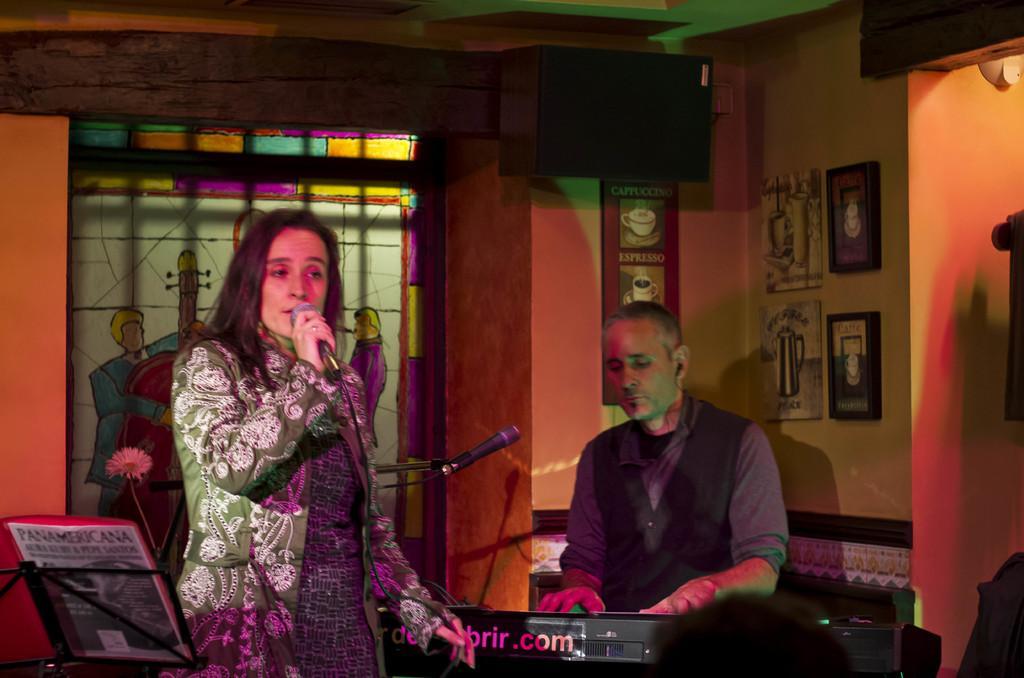In one or two sentences, can you explain what this image depicts? This picture is clicked inside a room. The woman to the left corner is holding a microphone in a hand and singing. The man to the right corner is playing keyboard and in front of him there is a microphone and its stand. To the extreme left corner there is a book holder and a book placed on it. On the wall there are many picture frames of coffee cups and water mugs. In the background there is wall and window. On the window there is a image of a person holding cello in his hand. There are speakers to the wall. 